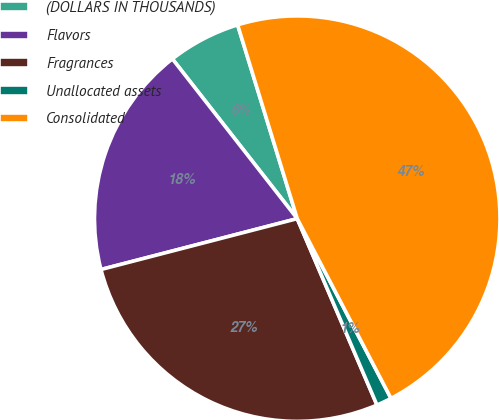<chart> <loc_0><loc_0><loc_500><loc_500><pie_chart><fcel>(DOLLARS IN THOUSANDS)<fcel>Flavors<fcel>Fragrances<fcel>Unallocated assets<fcel>Consolidated<nl><fcel>5.81%<fcel>18.48%<fcel>27.4%<fcel>1.22%<fcel>47.1%<nl></chart> 